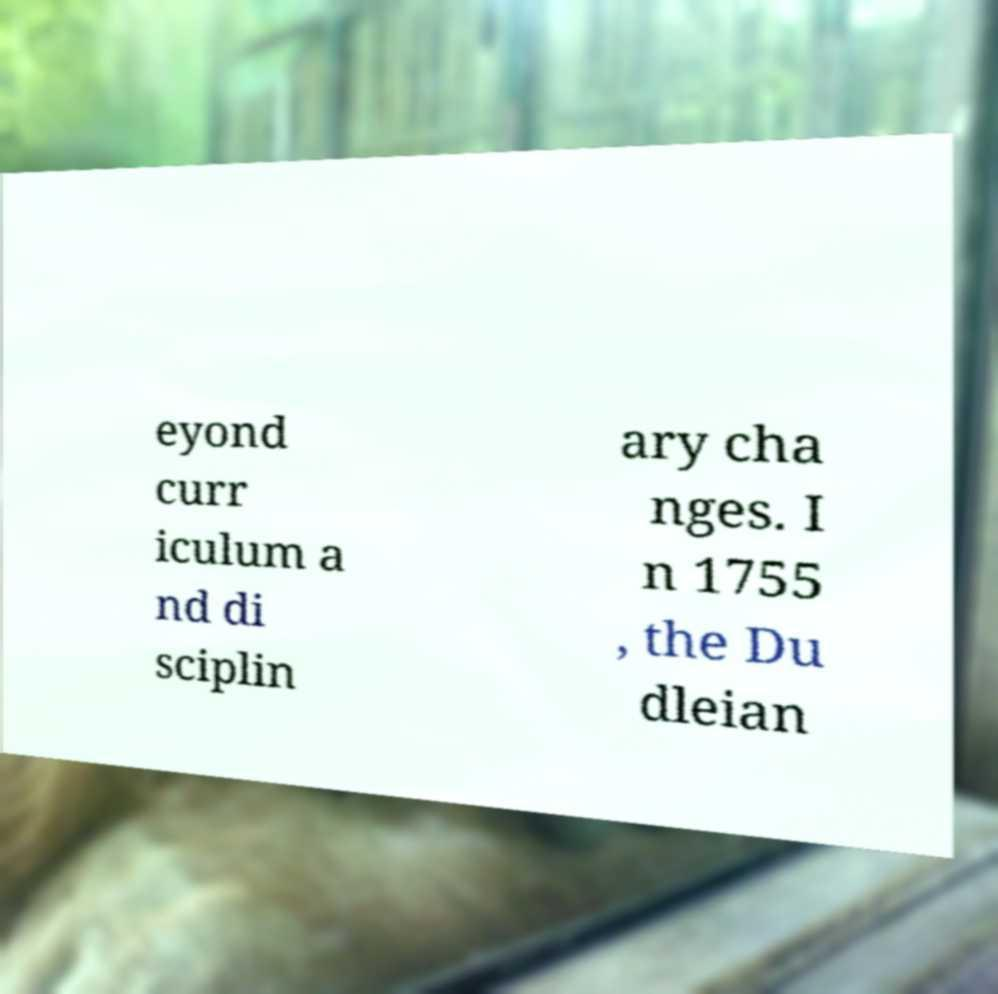For documentation purposes, I need the text within this image transcribed. Could you provide that? eyond curr iculum a nd di sciplin ary cha nges. I n 1755 , the Du dleian 